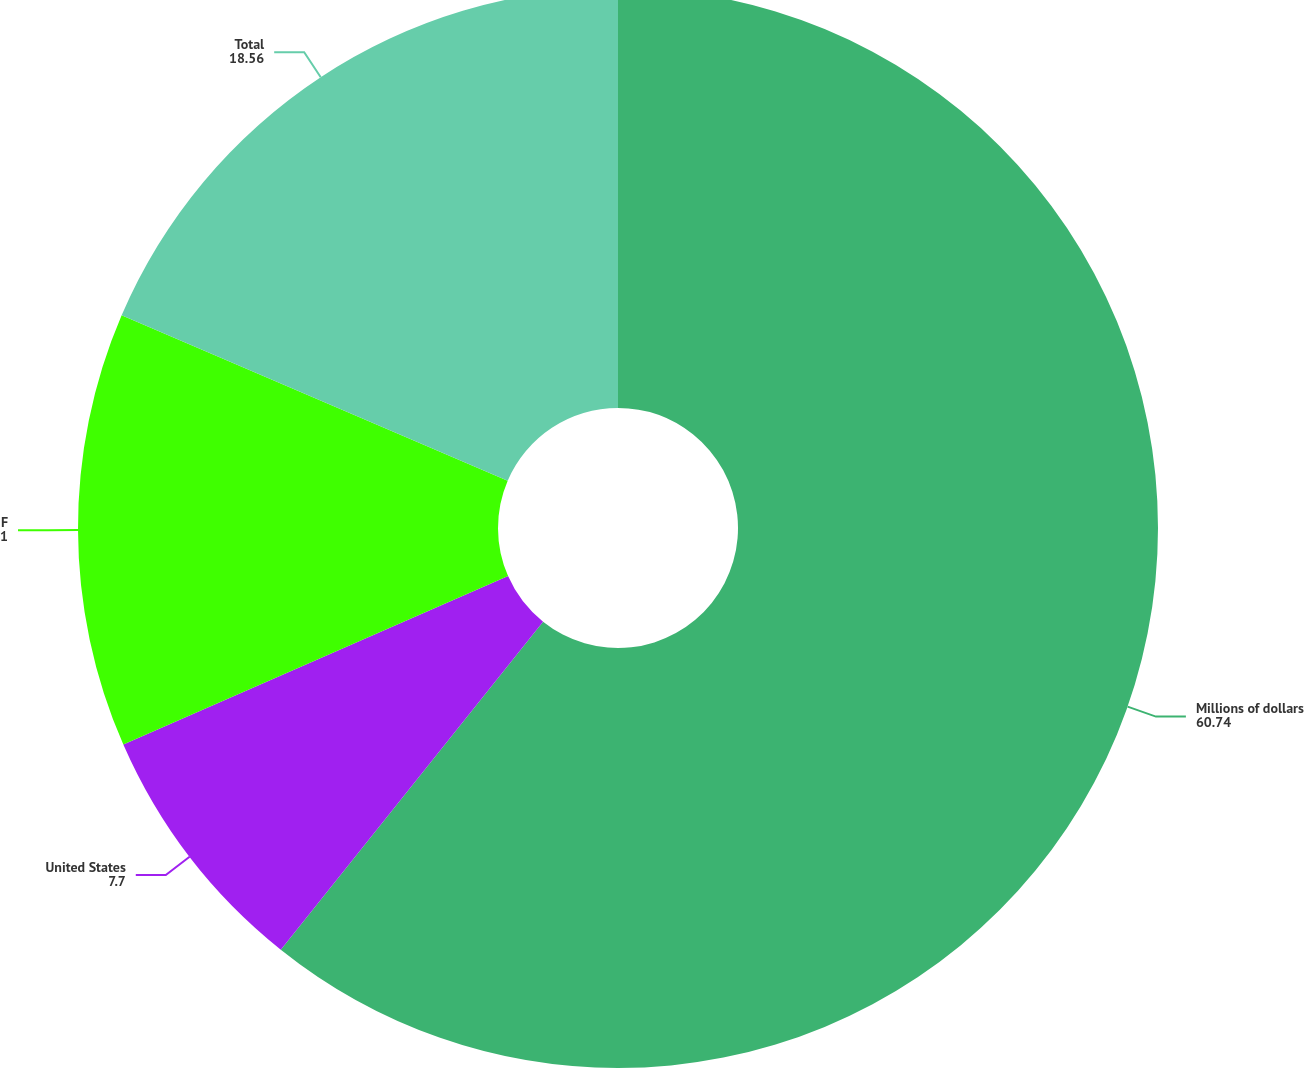<chart> <loc_0><loc_0><loc_500><loc_500><pie_chart><fcel>Millions of dollars<fcel>United States<fcel>Foreign<fcel>Total<nl><fcel>60.74%<fcel>7.7%<fcel>13.01%<fcel>18.56%<nl></chart> 